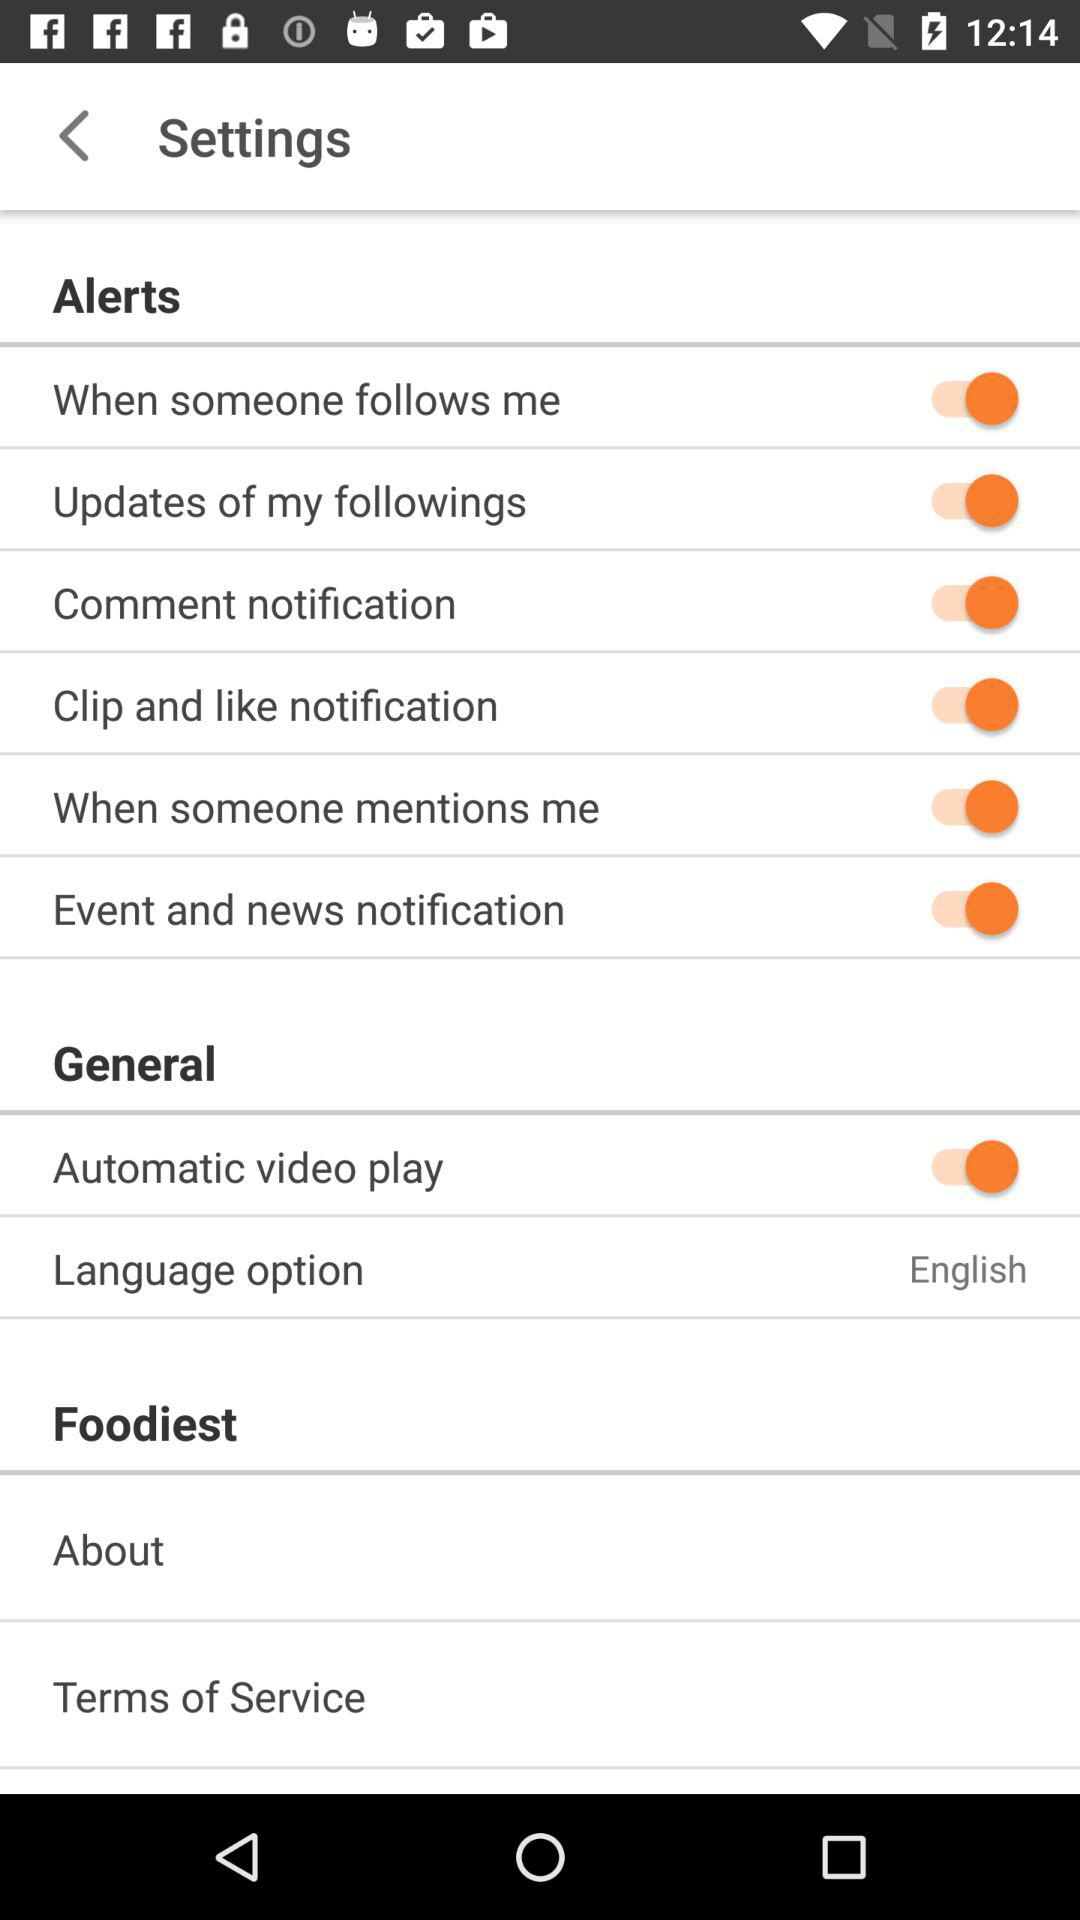Which language is selected? The selected language is English. 